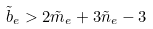Convert formula to latex. <formula><loc_0><loc_0><loc_500><loc_500>\tilde { b } _ { e } > 2 \tilde { m } _ { e } + 3 \tilde { n } _ { e } - 3</formula> 